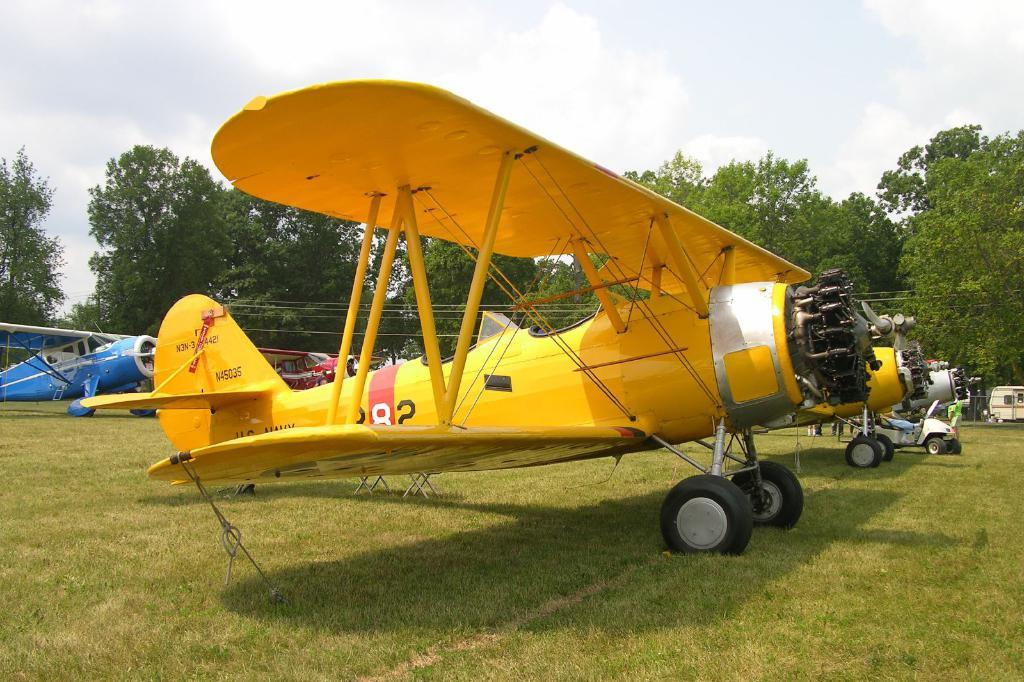<image>
Create a compact narrative representing the image presented. A yellow propeller plane has the identification number of N45035 on the tail. 